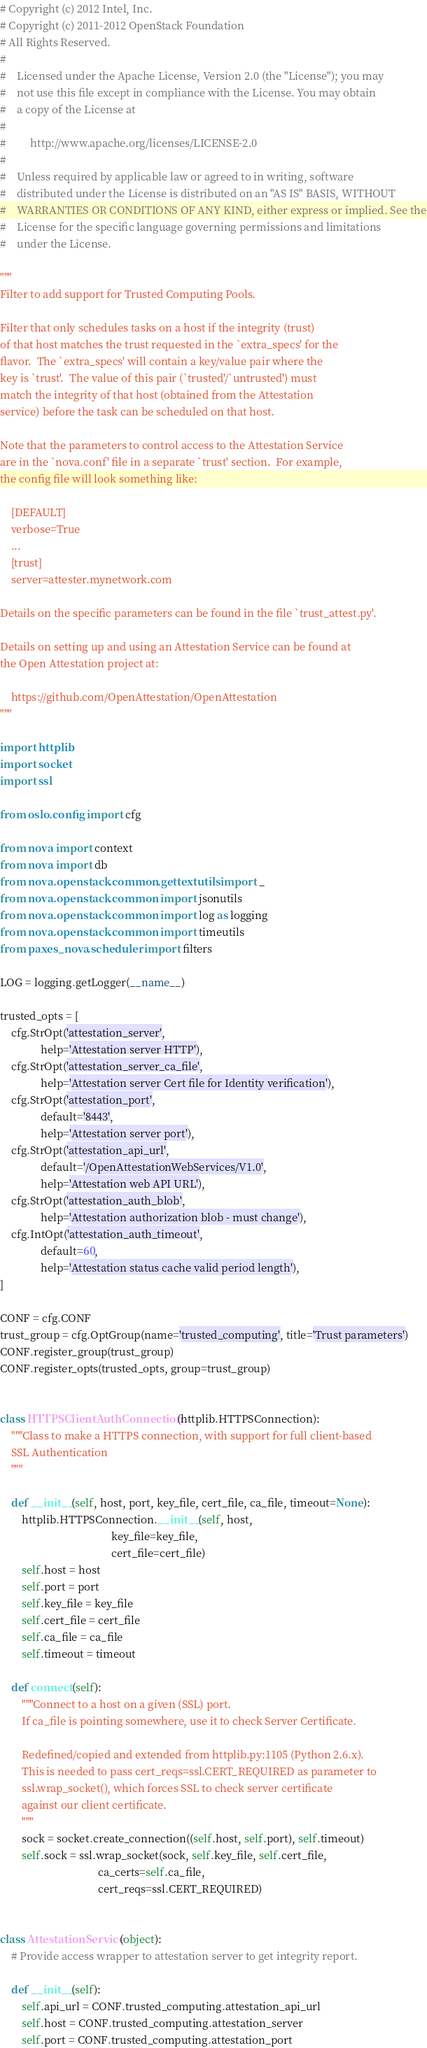<code> <loc_0><loc_0><loc_500><loc_500><_Python_># Copyright (c) 2012 Intel, Inc.
# Copyright (c) 2011-2012 OpenStack Foundation
# All Rights Reserved.
#
#    Licensed under the Apache License, Version 2.0 (the "License"); you may
#    not use this file except in compliance with the License. You may obtain
#    a copy of the License at
#
#         http://www.apache.org/licenses/LICENSE-2.0
#
#    Unless required by applicable law or agreed to in writing, software
#    distributed under the License is distributed on an "AS IS" BASIS, WITHOUT
#    WARRANTIES OR CONDITIONS OF ANY KIND, either express or implied. See the
#    License for the specific language governing permissions and limitations
#    under the License.

"""
Filter to add support for Trusted Computing Pools.

Filter that only schedules tasks on a host if the integrity (trust)
of that host matches the trust requested in the `extra_specs' for the
flavor.  The `extra_specs' will contain a key/value pair where the
key is `trust'.  The value of this pair (`trusted'/`untrusted') must
match the integrity of that host (obtained from the Attestation
service) before the task can be scheduled on that host.

Note that the parameters to control access to the Attestation Service
are in the `nova.conf' file in a separate `trust' section.  For example,
the config file will look something like:

    [DEFAULT]
    verbose=True
    ...
    [trust]
    server=attester.mynetwork.com

Details on the specific parameters can be found in the file `trust_attest.py'.

Details on setting up and using an Attestation Service can be found at
the Open Attestation project at:

    https://github.com/OpenAttestation/OpenAttestation
"""

import httplib
import socket
import ssl

from oslo.config import cfg

from nova import context
from nova import db
from nova.openstack.common.gettextutils import _
from nova.openstack.common import jsonutils
from nova.openstack.common import log as logging
from nova.openstack.common import timeutils
from paxes_nova.scheduler import filters

LOG = logging.getLogger(__name__)

trusted_opts = [
    cfg.StrOpt('attestation_server',
               help='Attestation server HTTP'),
    cfg.StrOpt('attestation_server_ca_file',
               help='Attestation server Cert file for Identity verification'),
    cfg.StrOpt('attestation_port',
               default='8443',
               help='Attestation server port'),
    cfg.StrOpt('attestation_api_url',
               default='/OpenAttestationWebServices/V1.0',
               help='Attestation web API URL'),
    cfg.StrOpt('attestation_auth_blob',
               help='Attestation authorization blob - must change'),
    cfg.IntOpt('attestation_auth_timeout',
               default=60,
               help='Attestation status cache valid period length'),
]

CONF = cfg.CONF
trust_group = cfg.OptGroup(name='trusted_computing', title='Trust parameters')
CONF.register_group(trust_group)
CONF.register_opts(trusted_opts, group=trust_group)


class HTTPSClientAuthConnection(httplib.HTTPSConnection):
    """Class to make a HTTPS connection, with support for full client-based
    SSL Authentication
    """

    def __init__(self, host, port, key_file, cert_file, ca_file, timeout=None):
        httplib.HTTPSConnection.__init__(self, host,
                                         key_file=key_file,
                                         cert_file=cert_file)
        self.host = host
        self.port = port
        self.key_file = key_file
        self.cert_file = cert_file
        self.ca_file = ca_file
        self.timeout = timeout

    def connect(self):
        """Connect to a host on a given (SSL) port.
        If ca_file is pointing somewhere, use it to check Server Certificate.

        Redefined/copied and extended from httplib.py:1105 (Python 2.6.x).
        This is needed to pass cert_reqs=ssl.CERT_REQUIRED as parameter to
        ssl.wrap_socket(), which forces SSL to check server certificate
        against our client certificate.
        """
        sock = socket.create_connection((self.host, self.port), self.timeout)
        self.sock = ssl.wrap_socket(sock, self.key_file, self.cert_file,
                                    ca_certs=self.ca_file,
                                    cert_reqs=ssl.CERT_REQUIRED)


class AttestationService(object):
    # Provide access wrapper to attestation server to get integrity report.

    def __init__(self):
        self.api_url = CONF.trusted_computing.attestation_api_url
        self.host = CONF.trusted_computing.attestation_server
        self.port = CONF.trusted_computing.attestation_port</code> 